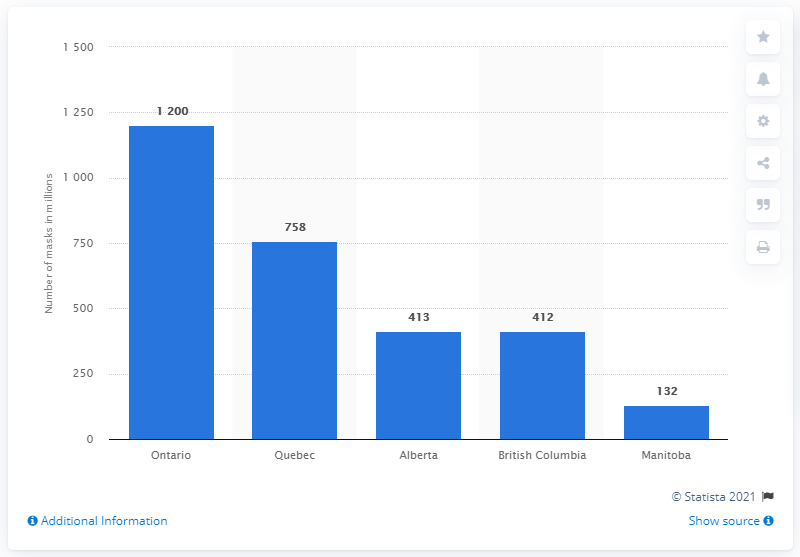Highlight a few significant elements in this photo. In May 2020, Ontario will require 1200 medical-surgical and non-medical grade face masks to address the potential spread of COVID-19. 